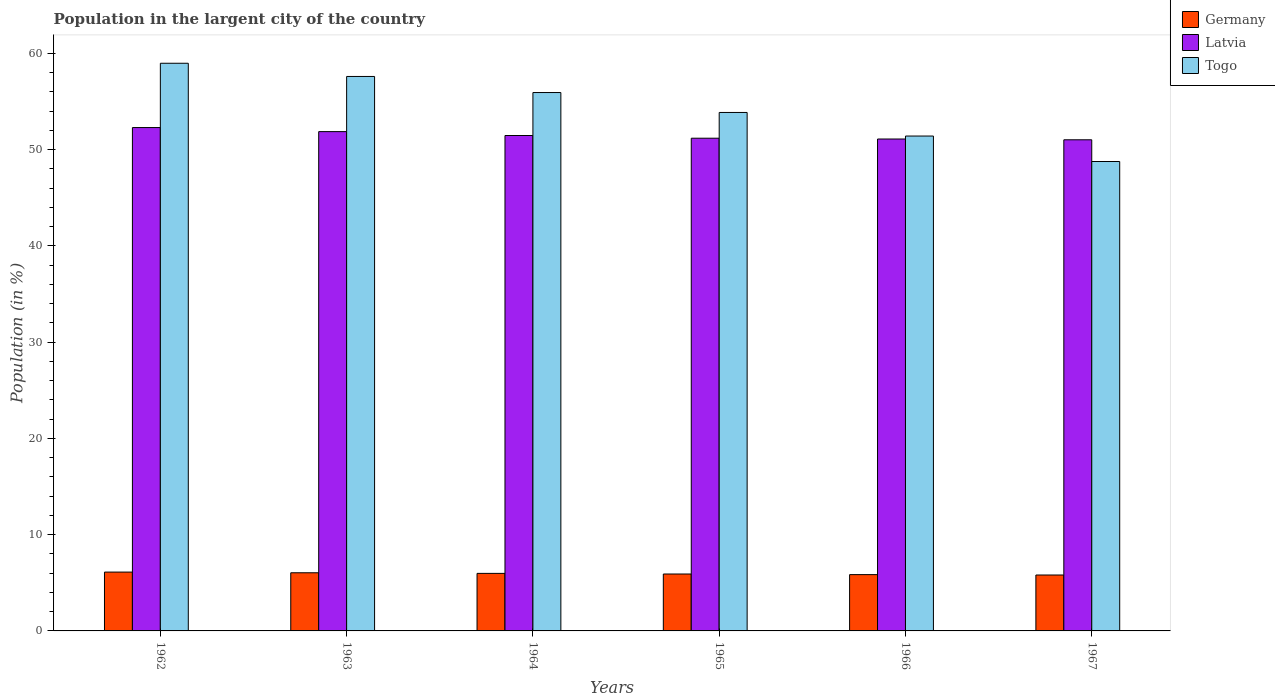How many groups of bars are there?
Offer a very short reply. 6. Are the number of bars per tick equal to the number of legend labels?
Keep it short and to the point. Yes. How many bars are there on the 2nd tick from the left?
Your answer should be very brief. 3. What is the label of the 4th group of bars from the left?
Your answer should be very brief. 1965. In how many cases, is the number of bars for a given year not equal to the number of legend labels?
Keep it short and to the point. 0. What is the percentage of population in the largent city in Togo in 1963?
Give a very brief answer. 57.61. Across all years, what is the maximum percentage of population in the largent city in Latvia?
Provide a short and direct response. 52.3. Across all years, what is the minimum percentage of population in the largent city in Germany?
Give a very brief answer. 5.81. In which year was the percentage of population in the largent city in Togo maximum?
Your response must be concise. 1962. In which year was the percentage of population in the largent city in Latvia minimum?
Your answer should be compact. 1967. What is the total percentage of population in the largent city in Togo in the graph?
Make the answer very short. 326.6. What is the difference between the percentage of population in the largent city in Latvia in 1965 and that in 1966?
Keep it short and to the point. 0.08. What is the difference between the percentage of population in the largent city in Germany in 1966 and the percentage of population in the largent city in Latvia in 1963?
Give a very brief answer. -46.03. What is the average percentage of population in the largent city in Latvia per year?
Your answer should be compact. 51.5. In the year 1964, what is the difference between the percentage of population in the largent city in Togo and percentage of population in the largent city in Germany?
Give a very brief answer. 49.96. What is the ratio of the percentage of population in the largent city in Germany in 1962 to that in 1967?
Your answer should be compact. 1.05. What is the difference between the highest and the second highest percentage of population in the largent city in Germany?
Your answer should be very brief. 0.07. What is the difference between the highest and the lowest percentage of population in the largent city in Latvia?
Provide a succinct answer. 1.27. In how many years, is the percentage of population in the largent city in Togo greater than the average percentage of population in the largent city in Togo taken over all years?
Keep it short and to the point. 3. Is the sum of the percentage of population in the largent city in Latvia in 1962 and 1964 greater than the maximum percentage of population in the largent city in Germany across all years?
Your answer should be compact. Yes. What does the 2nd bar from the left in 1962 represents?
Your answer should be compact. Latvia. What does the 2nd bar from the right in 1965 represents?
Give a very brief answer. Latvia. Is it the case that in every year, the sum of the percentage of population in the largent city in Togo and percentage of population in the largent city in Latvia is greater than the percentage of population in the largent city in Germany?
Give a very brief answer. Yes. Are all the bars in the graph horizontal?
Offer a very short reply. No. Does the graph contain grids?
Give a very brief answer. No. Where does the legend appear in the graph?
Your answer should be compact. Top right. How are the legend labels stacked?
Make the answer very short. Vertical. What is the title of the graph?
Provide a succinct answer. Population in the largent city of the country. What is the label or title of the Y-axis?
Give a very brief answer. Population (in %). What is the Population (in %) of Germany in 1962?
Your answer should be very brief. 6.11. What is the Population (in %) of Latvia in 1962?
Give a very brief answer. 52.3. What is the Population (in %) of Togo in 1962?
Ensure brevity in your answer.  58.98. What is the Population (in %) in Germany in 1963?
Ensure brevity in your answer.  6.04. What is the Population (in %) of Latvia in 1963?
Give a very brief answer. 51.88. What is the Population (in %) of Togo in 1963?
Your answer should be very brief. 57.61. What is the Population (in %) in Germany in 1964?
Keep it short and to the point. 5.98. What is the Population (in %) of Latvia in 1964?
Make the answer very short. 51.48. What is the Population (in %) in Togo in 1964?
Your answer should be compact. 55.94. What is the Population (in %) of Germany in 1965?
Offer a terse response. 5.91. What is the Population (in %) of Latvia in 1965?
Give a very brief answer. 51.19. What is the Population (in %) in Togo in 1965?
Offer a very short reply. 53.87. What is the Population (in %) in Germany in 1966?
Provide a short and direct response. 5.85. What is the Population (in %) of Latvia in 1966?
Ensure brevity in your answer.  51.11. What is the Population (in %) of Togo in 1966?
Provide a succinct answer. 51.42. What is the Population (in %) of Germany in 1967?
Your answer should be very brief. 5.81. What is the Population (in %) of Latvia in 1967?
Your answer should be very brief. 51.03. What is the Population (in %) in Togo in 1967?
Your answer should be compact. 48.77. Across all years, what is the maximum Population (in %) of Germany?
Your answer should be very brief. 6.11. Across all years, what is the maximum Population (in %) in Latvia?
Your response must be concise. 52.3. Across all years, what is the maximum Population (in %) in Togo?
Your answer should be compact. 58.98. Across all years, what is the minimum Population (in %) in Germany?
Make the answer very short. 5.81. Across all years, what is the minimum Population (in %) of Latvia?
Ensure brevity in your answer.  51.03. Across all years, what is the minimum Population (in %) of Togo?
Your answer should be very brief. 48.77. What is the total Population (in %) of Germany in the graph?
Give a very brief answer. 35.71. What is the total Population (in %) of Latvia in the graph?
Make the answer very short. 309. What is the total Population (in %) of Togo in the graph?
Your response must be concise. 326.6. What is the difference between the Population (in %) of Germany in 1962 and that in 1963?
Offer a terse response. 0.07. What is the difference between the Population (in %) of Latvia in 1962 and that in 1963?
Your answer should be compact. 0.42. What is the difference between the Population (in %) in Togo in 1962 and that in 1963?
Give a very brief answer. 1.37. What is the difference between the Population (in %) in Germany in 1962 and that in 1964?
Provide a short and direct response. 0.13. What is the difference between the Population (in %) of Latvia in 1962 and that in 1964?
Make the answer very short. 0.83. What is the difference between the Population (in %) in Togo in 1962 and that in 1964?
Provide a short and direct response. 3.04. What is the difference between the Population (in %) of Germany in 1962 and that in 1965?
Make the answer very short. 0.2. What is the difference between the Population (in %) in Latvia in 1962 and that in 1965?
Your answer should be compact. 1.11. What is the difference between the Population (in %) of Togo in 1962 and that in 1965?
Your response must be concise. 5.11. What is the difference between the Population (in %) of Germany in 1962 and that in 1966?
Keep it short and to the point. 0.26. What is the difference between the Population (in %) in Latvia in 1962 and that in 1966?
Provide a short and direct response. 1.19. What is the difference between the Population (in %) in Togo in 1962 and that in 1966?
Provide a short and direct response. 7.56. What is the difference between the Population (in %) of Germany in 1962 and that in 1967?
Offer a terse response. 0.3. What is the difference between the Population (in %) of Latvia in 1962 and that in 1967?
Your answer should be compact. 1.27. What is the difference between the Population (in %) in Togo in 1962 and that in 1967?
Offer a very short reply. 10.21. What is the difference between the Population (in %) of Germany in 1963 and that in 1964?
Provide a short and direct response. 0.06. What is the difference between the Population (in %) of Latvia in 1963 and that in 1964?
Offer a terse response. 0.4. What is the difference between the Population (in %) in Togo in 1963 and that in 1964?
Offer a terse response. 1.67. What is the difference between the Population (in %) in Germany in 1963 and that in 1965?
Offer a terse response. 0.13. What is the difference between the Population (in %) of Latvia in 1963 and that in 1965?
Offer a very short reply. 0.69. What is the difference between the Population (in %) of Togo in 1963 and that in 1965?
Offer a terse response. 3.74. What is the difference between the Population (in %) of Germany in 1963 and that in 1966?
Provide a short and direct response. 0.19. What is the difference between the Population (in %) of Latvia in 1963 and that in 1966?
Your answer should be very brief. 0.77. What is the difference between the Population (in %) in Togo in 1963 and that in 1966?
Offer a terse response. 6.19. What is the difference between the Population (in %) of Germany in 1963 and that in 1967?
Provide a short and direct response. 0.23. What is the difference between the Population (in %) of Latvia in 1963 and that in 1967?
Provide a short and direct response. 0.85. What is the difference between the Population (in %) in Togo in 1963 and that in 1967?
Make the answer very short. 8.84. What is the difference between the Population (in %) in Germany in 1964 and that in 1965?
Offer a terse response. 0.07. What is the difference between the Population (in %) in Latvia in 1964 and that in 1965?
Offer a terse response. 0.28. What is the difference between the Population (in %) of Togo in 1964 and that in 1965?
Offer a terse response. 2.07. What is the difference between the Population (in %) in Germany in 1964 and that in 1966?
Make the answer very short. 0.13. What is the difference between the Population (in %) in Latvia in 1964 and that in 1966?
Provide a short and direct response. 0.36. What is the difference between the Population (in %) in Togo in 1964 and that in 1966?
Offer a very short reply. 4.52. What is the difference between the Population (in %) in Germany in 1964 and that in 1967?
Keep it short and to the point. 0.17. What is the difference between the Population (in %) of Latvia in 1964 and that in 1967?
Ensure brevity in your answer.  0.44. What is the difference between the Population (in %) in Togo in 1964 and that in 1967?
Ensure brevity in your answer.  7.17. What is the difference between the Population (in %) of Germany in 1965 and that in 1966?
Your answer should be compact. 0.06. What is the difference between the Population (in %) of Latvia in 1965 and that in 1966?
Keep it short and to the point. 0.08. What is the difference between the Population (in %) of Togo in 1965 and that in 1966?
Your response must be concise. 2.45. What is the difference between the Population (in %) in Germany in 1965 and that in 1967?
Keep it short and to the point. 0.1. What is the difference between the Population (in %) of Latvia in 1965 and that in 1967?
Your answer should be compact. 0.16. What is the difference between the Population (in %) of Togo in 1965 and that in 1967?
Provide a succinct answer. 5.1. What is the difference between the Population (in %) of Germany in 1966 and that in 1967?
Give a very brief answer. 0.04. What is the difference between the Population (in %) in Latvia in 1966 and that in 1967?
Keep it short and to the point. 0.08. What is the difference between the Population (in %) in Togo in 1966 and that in 1967?
Offer a terse response. 2.65. What is the difference between the Population (in %) of Germany in 1962 and the Population (in %) of Latvia in 1963?
Your answer should be compact. -45.77. What is the difference between the Population (in %) of Germany in 1962 and the Population (in %) of Togo in 1963?
Ensure brevity in your answer.  -51.5. What is the difference between the Population (in %) of Latvia in 1962 and the Population (in %) of Togo in 1963?
Provide a succinct answer. -5.31. What is the difference between the Population (in %) of Germany in 1962 and the Population (in %) of Latvia in 1964?
Your response must be concise. -45.36. What is the difference between the Population (in %) in Germany in 1962 and the Population (in %) in Togo in 1964?
Ensure brevity in your answer.  -49.83. What is the difference between the Population (in %) of Latvia in 1962 and the Population (in %) of Togo in 1964?
Your answer should be very brief. -3.64. What is the difference between the Population (in %) in Germany in 1962 and the Population (in %) in Latvia in 1965?
Keep it short and to the point. -45.08. What is the difference between the Population (in %) of Germany in 1962 and the Population (in %) of Togo in 1965?
Give a very brief answer. -47.76. What is the difference between the Population (in %) of Latvia in 1962 and the Population (in %) of Togo in 1965?
Offer a terse response. -1.57. What is the difference between the Population (in %) of Germany in 1962 and the Population (in %) of Latvia in 1966?
Your response must be concise. -45. What is the difference between the Population (in %) of Germany in 1962 and the Population (in %) of Togo in 1966?
Offer a very short reply. -45.31. What is the difference between the Population (in %) of Latvia in 1962 and the Population (in %) of Togo in 1966?
Keep it short and to the point. 0.88. What is the difference between the Population (in %) in Germany in 1962 and the Population (in %) in Latvia in 1967?
Provide a short and direct response. -44.92. What is the difference between the Population (in %) of Germany in 1962 and the Population (in %) of Togo in 1967?
Your answer should be very brief. -42.66. What is the difference between the Population (in %) of Latvia in 1962 and the Population (in %) of Togo in 1967?
Your response must be concise. 3.53. What is the difference between the Population (in %) of Germany in 1963 and the Population (in %) of Latvia in 1964?
Keep it short and to the point. -45.43. What is the difference between the Population (in %) in Germany in 1963 and the Population (in %) in Togo in 1964?
Provide a succinct answer. -49.9. What is the difference between the Population (in %) in Latvia in 1963 and the Population (in %) in Togo in 1964?
Provide a succinct answer. -4.06. What is the difference between the Population (in %) of Germany in 1963 and the Population (in %) of Latvia in 1965?
Keep it short and to the point. -45.15. What is the difference between the Population (in %) of Germany in 1963 and the Population (in %) of Togo in 1965?
Provide a short and direct response. -47.83. What is the difference between the Population (in %) of Latvia in 1963 and the Population (in %) of Togo in 1965?
Keep it short and to the point. -1.99. What is the difference between the Population (in %) of Germany in 1963 and the Population (in %) of Latvia in 1966?
Provide a short and direct response. -45.07. What is the difference between the Population (in %) in Germany in 1963 and the Population (in %) in Togo in 1966?
Offer a very short reply. -45.38. What is the difference between the Population (in %) of Latvia in 1963 and the Population (in %) of Togo in 1966?
Provide a short and direct response. 0.46. What is the difference between the Population (in %) of Germany in 1963 and the Population (in %) of Latvia in 1967?
Make the answer very short. -44.99. What is the difference between the Population (in %) of Germany in 1963 and the Population (in %) of Togo in 1967?
Your answer should be compact. -42.73. What is the difference between the Population (in %) in Latvia in 1963 and the Population (in %) in Togo in 1967?
Keep it short and to the point. 3.1. What is the difference between the Population (in %) of Germany in 1964 and the Population (in %) of Latvia in 1965?
Offer a very short reply. -45.22. What is the difference between the Population (in %) in Germany in 1964 and the Population (in %) in Togo in 1965?
Your response must be concise. -47.89. What is the difference between the Population (in %) in Latvia in 1964 and the Population (in %) in Togo in 1965?
Make the answer very short. -2.4. What is the difference between the Population (in %) in Germany in 1964 and the Population (in %) in Latvia in 1966?
Your answer should be compact. -45.13. What is the difference between the Population (in %) in Germany in 1964 and the Population (in %) in Togo in 1966?
Your answer should be compact. -45.44. What is the difference between the Population (in %) in Latvia in 1964 and the Population (in %) in Togo in 1966?
Offer a terse response. 0.06. What is the difference between the Population (in %) in Germany in 1964 and the Population (in %) in Latvia in 1967?
Provide a short and direct response. -45.05. What is the difference between the Population (in %) of Germany in 1964 and the Population (in %) of Togo in 1967?
Offer a terse response. -42.8. What is the difference between the Population (in %) of Latvia in 1964 and the Population (in %) of Togo in 1967?
Keep it short and to the point. 2.7. What is the difference between the Population (in %) in Germany in 1965 and the Population (in %) in Latvia in 1966?
Your answer should be very brief. -45.2. What is the difference between the Population (in %) in Germany in 1965 and the Population (in %) in Togo in 1966?
Your answer should be compact. -45.51. What is the difference between the Population (in %) of Latvia in 1965 and the Population (in %) of Togo in 1966?
Offer a terse response. -0.23. What is the difference between the Population (in %) in Germany in 1965 and the Population (in %) in Latvia in 1967?
Offer a very short reply. -45.12. What is the difference between the Population (in %) in Germany in 1965 and the Population (in %) in Togo in 1967?
Your answer should be compact. -42.86. What is the difference between the Population (in %) of Latvia in 1965 and the Population (in %) of Togo in 1967?
Your answer should be compact. 2.42. What is the difference between the Population (in %) in Germany in 1966 and the Population (in %) in Latvia in 1967?
Offer a very short reply. -45.18. What is the difference between the Population (in %) of Germany in 1966 and the Population (in %) of Togo in 1967?
Your response must be concise. -42.92. What is the difference between the Population (in %) of Latvia in 1966 and the Population (in %) of Togo in 1967?
Offer a very short reply. 2.34. What is the average Population (in %) in Germany per year?
Your answer should be very brief. 5.95. What is the average Population (in %) in Latvia per year?
Offer a very short reply. 51.5. What is the average Population (in %) in Togo per year?
Provide a short and direct response. 54.43. In the year 1962, what is the difference between the Population (in %) in Germany and Population (in %) in Latvia?
Provide a short and direct response. -46.19. In the year 1962, what is the difference between the Population (in %) in Germany and Population (in %) in Togo?
Your answer should be very brief. -52.87. In the year 1962, what is the difference between the Population (in %) in Latvia and Population (in %) in Togo?
Keep it short and to the point. -6.68. In the year 1963, what is the difference between the Population (in %) of Germany and Population (in %) of Latvia?
Offer a terse response. -45.84. In the year 1963, what is the difference between the Population (in %) of Germany and Population (in %) of Togo?
Your response must be concise. -51.57. In the year 1963, what is the difference between the Population (in %) in Latvia and Population (in %) in Togo?
Offer a terse response. -5.73. In the year 1964, what is the difference between the Population (in %) in Germany and Population (in %) in Latvia?
Offer a very short reply. -45.5. In the year 1964, what is the difference between the Population (in %) of Germany and Population (in %) of Togo?
Provide a succinct answer. -49.96. In the year 1964, what is the difference between the Population (in %) of Latvia and Population (in %) of Togo?
Give a very brief answer. -4.46. In the year 1965, what is the difference between the Population (in %) in Germany and Population (in %) in Latvia?
Your response must be concise. -45.28. In the year 1965, what is the difference between the Population (in %) in Germany and Population (in %) in Togo?
Offer a very short reply. -47.96. In the year 1965, what is the difference between the Population (in %) of Latvia and Population (in %) of Togo?
Give a very brief answer. -2.68. In the year 1966, what is the difference between the Population (in %) of Germany and Population (in %) of Latvia?
Provide a succinct answer. -45.26. In the year 1966, what is the difference between the Population (in %) in Germany and Population (in %) in Togo?
Ensure brevity in your answer.  -45.57. In the year 1966, what is the difference between the Population (in %) in Latvia and Population (in %) in Togo?
Keep it short and to the point. -0.31. In the year 1967, what is the difference between the Population (in %) of Germany and Population (in %) of Latvia?
Your answer should be compact. -45.22. In the year 1967, what is the difference between the Population (in %) in Germany and Population (in %) in Togo?
Your answer should be very brief. -42.97. In the year 1967, what is the difference between the Population (in %) of Latvia and Population (in %) of Togo?
Offer a terse response. 2.26. What is the ratio of the Population (in %) in Germany in 1962 to that in 1963?
Offer a very short reply. 1.01. What is the ratio of the Population (in %) of Togo in 1962 to that in 1963?
Your response must be concise. 1.02. What is the ratio of the Population (in %) in Germany in 1962 to that in 1964?
Your response must be concise. 1.02. What is the ratio of the Population (in %) in Latvia in 1962 to that in 1964?
Make the answer very short. 1.02. What is the ratio of the Population (in %) in Togo in 1962 to that in 1964?
Make the answer very short. 1.05. What is the ratio of the Population (in %) in Germany in 1962 to that in 1965?
Give a very brief answer. 1.03. What is the ratio of the Population (in %) of Latvia in 1962 to that in 1965?
Provide a short and direct response. 1.02. What is the ratio of the Population (in %) in Togo in 1962 to that in 1965?
Offer a very short reply. 1.09. What is the ratio of the Population (in %) in Germany in 1962 to that in 1966?
Give a very brief answer. 1.04. What is the ratio of the Population (in %) in Latvia in 1962 to that in 1966?
Provide a succinct answer. 1.02. What is the ratio of the Population (in %) in Togo in 1962 to that in 1966?
Offer a terse response. 1.15. What is the ratio of the Population (in %) of Germany in 1962 to that in 1967?
Provide a short and direct response. 1.05. What is the ratio of the Population (in %) in Latvia in 1962 to that in 1967?
Your answer should be compact. 1.02. What is the ratio of the Population (in %) of Togo in 1962 to that in 1967?
Make the answer very short. 1.21. What is the ratio of the Population (in %) in Germany in 1963 to that in 1964?
Provide a short and direct response. 1.01. What is the ratio of the Population (in %) of Latvia in 1963 to that in 1964?
Offer a terse response. 1.01. What is the ratio of the Population (in %) in Togo in 1963 to that in 1964?
Give a very brief answer. 1.03. What is the ratio of the Population (in %) in Germany in 1963 to that in 1965?
Your answer should be compact. 1.02. What is the ratio of the Population (in %) of Latvia in 1963 to that in 1965?
Give a very brief answer. 1.01. What is the ratio of the Population (in %) in Togo in 1963 to that in 1965?
Keep it short and to the point. 1.07. What is the ratio of the Population (in %) in Germany in 1963 to that in 1966?
Keep it short and to the point. 1.03. What is the ratio of the Population (in %) of Latvia in 1963 to that in 1966?
Your response must be concise. 1.01. What is the ratio of the Population (in %) in Togo in 1963 to that in 1966?
Your answer should be compact. 1.12. What is the ratio of the Population (in %) in Germany in 1963 to that in 1967?
Your answer should be very brief. 1.04. What is the ratio of the Population (in %) in Latvia in 1963 to that in 1967?
Offer a terse response. 1.02. What is the ratio of the Population (in %) in Togo in 1963 to that in 1967?
Your answer should be compact. 1.18. What is the ratio of the Population (in %) in Germany in 1964 to that in 1965?
Your answer should be compact. 1.01. What is the ratio of the Population (in %) in Latvia in 1964 to that in 1965?
Make the answer very short. 1.01. What is the ratio of the Population (in %) in Togo in 1964 to that in 1965?
Make the answer very short. 1.04. What is the ratio of the Population (in %) of Germany in 1964 to that in 1966?
Offer a terse response. 1.02. What is the ratio of the Population (in %) in Latvia in 1964 to that in 1966?
Give a very brief answer. 1.01. What is the ratio of the Population (in %) of Togo in 1964 to that in 1966?
Provide a short and direct response. 1.09. What is the ratio of the Population (in %) in Germany in 1964 to that in 1967?
Keep it short and to the point. 1.03. What is the ratio of the Population (in %) of Latvia in 1964 to that in 1967?
Give a very brief answer. 1.01. What is the ratio of the Population (in %) of Togo in 1964 to that in 1967?
Your answer should be very brief. 1.15. What is the ratio of the Population (in %) in Germany in 1965 to that in 1966?
Your response must be concise. 1.01. What is the ratio of the Population (in %) of Latvia in 1965 to that in 1966?
Offer a terse response. 1. What is the ratio of the Population (in %) of Togo in 1965 to that in 1966?
Make the answer very short. 1.05. What is the ratio of the Population (in %) of Latvia in 1965 to that in 1967?
Make the answer very short. 1. What is the ratio of the Population (in %) in Togo in 1965 to that in 1967?
Offer a terse response. 1.1. What is the ratio of the Population (in %) of Germany in 1966 to that in 1967?
Your answer should be very brief. 1.01. What is the ratio of the Population (in %) in Latvia in 1966 to that in 1967?
Offer a terse response. 1. What is the ratio of the Population (in %) of Togo in 1966 to that in 1967?
Your answer should be compact. 1.05. What is the difference between the highest and the second highest Population (in %) of Germany?
Provide a succinct answer. 0.07. What is the difference between the highest and the second highest Population (in %) in Latvia?
Make the answer very short. 0.42. What is the difference between the highest and the second highest Population (in %) in Togo?
Give a very brief answer. 1.37. What is the difference between the highest and the lowest Population (in %) of Germany?
Provide a short and direct response. 0.3. What is the difference between the highest and the lowest Population (in %) of Latvia?
Your response must be concise. 1.27. What is the difference between the highest and the lowest Population (in %) in Togo?
Keep it short and to the point. 10.21. 